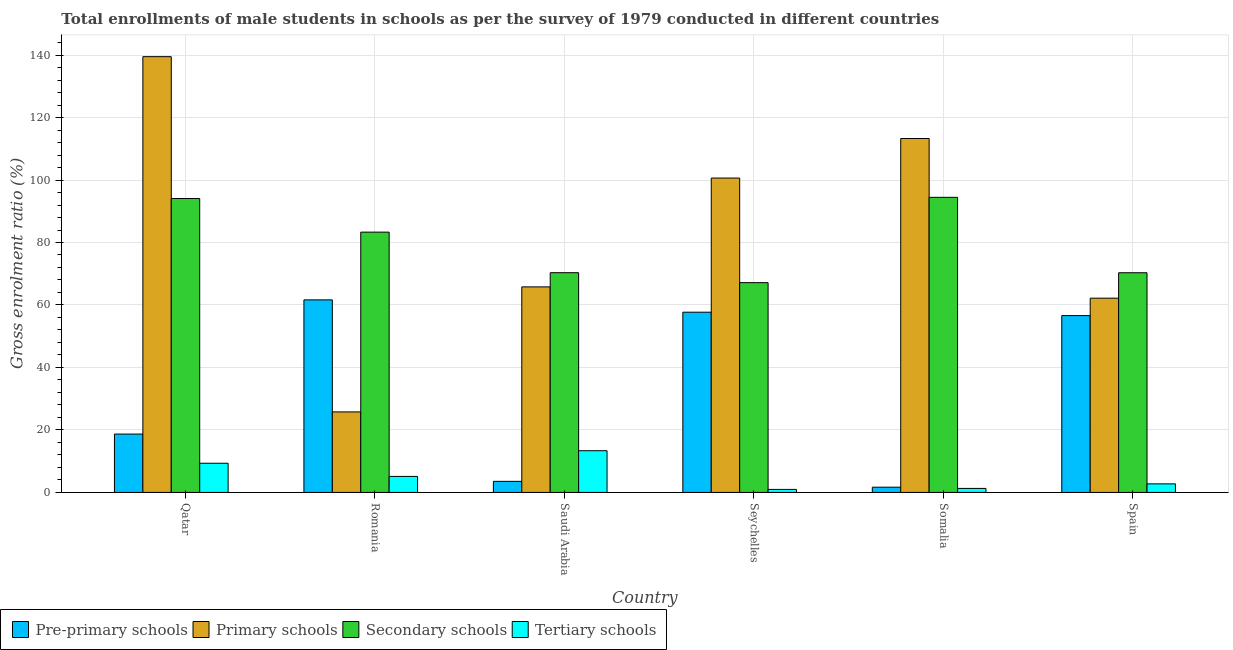How many groups of bars are there?
Offer a terse response. 6. How many bars are there on the 3rd tick from the left?
Offer a terse response. 4. How many bars are there on the 1st tick from the right?
Give a very brief answer. 4. What is the label of the 5th group of bars from the left?
Your answer should be very brief. Somalia. In how many cases, is the number of bars for a given country not equal to the number of legend labels?
Your answer should be very brief. 0. What is the gross enrolment ratio(male) in tertiary schools in Somalia?
Your answer should be very brief. 1.29. Across all countries, what is the maximum gross enrolment ratio(male) in secondary schools?
Ensure brevity in your answer.  94.46. Across all countries, what is the minimum gross enrolment ratio(male) in tertiary schools?
Keep it short and to the point. 0.97. In which country was the gross enrolment ratio(male) in pre-primary schools maximum?
Ensure brevity in your answer.  Romania. In which country was the gross enrolment ratio(male) in primary schools minimum?
Your answer should be very brief. Romania. What is the total gross enrolment ratio(male) in primary schools in the graph?
Ensure brevity in your answer.  507.15. What is the difference between the gross enrolment ratio(male) in primary schools in Seychelles and that in Spain?
Make the answer very short. 38.44. What is the difference between the gross enrolment ratio(male) in tertiary schools in Qatar and the gross enrolment ratio(male) in secondary schools in Romania?
Offer a very short reply. -73.97. What is the average gross enrolment ratio(male) in secondary schools per country?
Offer a very short reply. 79.94. What is the difference between the gross enrolment ratio(male) in tertiary schools and gross enrolment ratio(male) in primary schools in Qatar?
Provide a succinct answer. -130.14. In how many countries, is the gross enrolment ratio(male) in tertiary schools greater than 108 %?
Offer a terse response. 0. What is the ratio of the gross enrolment ratio(male) in primary schools in Romania to that in Spain?
Your answer should be very brief. 0.41. Is the gross enrolment ratio(male) in pre-primary schools in Romania less than that in Seychelles?
Keep it short and to the point. No. Is the difference between the gross enrolment ratio(male) in secondary schools in Qatar and Spain greater than the difference between the gross enrolment ratio(male) in primary schools in Qatar and Spain?
Your response must be concise. No. What is the difference between the highest and the second highest gross enrolment ratio(male) in primary schools?
Give a very brief answer. 26.19. What is the difference between the highest and the lowest gross enrolment ratio(male) in pre-primary schools?
Your response must be concise. 59.96. What does the 2nd bar from the left in Spain represents?
Make the answer very short. Primary schools. What does the 3rd bar from the right in Spain represents?
Offer a very short reply. Primary schools. Are all the bars in the graph horizontal?
Offer a very short reply. No. Are the values on the major ticks of Y-axis written in scientific E-notation?
Offer a very short reply. No. Does the graph contain grids?
Provide a succinct answer. Yes. Where does the legend appear in the graph?
Offer a terse response. Bottom left. What is the title of the graph?
Make the answer very short. Total enrollments of male students in schools as per the survey of 1979 conducted in different countries. What is the label or title of the X-axis?
Make the answer very short. Country. What is the Gross enrolment ratio (%) in Pre-primary schools in Qatar?
Give a very brief answer. 18.68. What is the Gross enrolment ratio (%) of Primary schools in Qatar?
Provide a short and direct response. 139.48. What is the Gross enrolment ratio (%) of Secondary schools in Qatar?
Offer a terse response. 94.08. What is the Gross enrolment ratio (%) in Tertiary schools in Qatar?
Your answer should be compact. 9.34. What is the Gross enrolment ratio (%) in Pre-primary schools in Romania?
Your response must be concise. 61.64. What is the Gross enrolment ratio (%) of Primary schools in Romania?
Offer a terse response. 25.77. What is the Gross enrolment ratio (%) of Secondary schools in Romania?
Offer a very short reply. 83.32. What is the Gross enrolment ratio (%) in Tertiary schools in Romania?
Give a very brief answer. 5.13. What is the Gross enrolment ratio (%) in Pre-primary schools in Saudi Arabia?
Offer a very short reply. 3.55. What is the Gross enrolment ratio (%) of Primary schools in Saudi Arabia?
Make the answer very short. 65.8. What is the Gross enrolment ratio (%) of Secondary schools in Saudi Arabia?
Your answer should be very brief. 70.33. What is the Gross enrolment ratio (%) in Tertiary schools in Saudi Arabia?
Your answer should be very brief. 13.35. What is the Gross enrolment ratio (%) in Pre-primary schools in Seychelles?
Make the answer very short. 57.69. What is the Gross enrolment ratio (%) of Primary schools in Seychelles?
Your answer should be very brief. 100.63. What is the Gross enrolment ratio (%) in Secondary schools in Seychelles?
Give a very brief answer. 67.15. What is the Gross enrolment ratio (%) in Tertiary schools in Seychelles?
Your response must be concise. 0.97. What is the Gross enrolment ratio (%) of Pre-primary schools in Somalia?
Give a very brief answer. 1.68. What is the Gross enrolment ratio (%) in Primary schools in Somalia?
Make the answer very short. 113.29. What is the Gross enrolment ratio (%) of Secondary schools in Somalia?
Your answer should be very brief. 94.46. What is the Gross enrolment ratio (%) in Tertiary schools in Somalia?
Make the answer very short. 1.29. What is the Gross enrolment ratio (%) of Pre-primary schools in Spain?
Your response must be concise. 56.6. What is the Gross enrolment ratio (%) of Primary schools in Spain?
Your answer should be compact. 62.18. What is the Gross enrolment ratio (%) of Secondary schools in Spain?
Ensure brevity in your answer.  70.32. What is the Gross enrolment ratio (%) of Tertiary schools in Spain?
Provide a short and direct response. 2.74. Across all countries, what is the maximum Gross enrolment ratio (%) of Pre-primary schools?
Keep it short and to the point. 61.64. Across all countries, what is the maximum Gross enrolment ratio (%) of Primary schools?
Ensure brevity in your answer.  139.48. Across all countries, what is the maximum Gross enrolment ratio (%) in Secondary schools?
Provide a succinct answer. 94.46. Across all countries, what is the maximum Gross enrolment ratio (%) of Tertiary schools?
Your answer should be compact. 13.35. Across all countries, what is the minimum Gross enrolment ratio (%) in Pre-primary schools?
Your response must be concise. 1.68. Across all countries, what is the minimum Gross enrolment ratio (%) of Primary schools?
Your answer should be very brief. 25.77. Across all countries, what is the minimum Gross enrolment ratio (%) in Secondary schools?
Your response must be concise. 67.15. Across all countries, what is the minimum Gross enrolment ratio (%) of Tertiary schools?
Make the answer very short. 0.97. What is the total Gross enrolment ratio (%) in Pre-primary schools in the graph?
Your answer should be very brief. 199.83. What is the total Gross enrolment ratio (%) of Primary schools in the graph?
Provide a short and direct response. 507.15. What is the total Gross enrolment ratio (%) in Secondary schools in the graph?
Offer a very short reply. 479.66. What is the total Gross enrolment ratio (%) of Tertiary schools in the graph?
Your answer should be very brief. 32.83. What is the difference between the Gross enrolment ratio (%) of Pre-primary schools in Qatar and that in Romania?
Make the answer very short. -42.95. What is the difference between the Gross enrolment ratio (%) of Primary schools in Qatar and that in Romania?
Make the answer very short. 113.71. What is the difference between the Gross enrolment ratio (%) in Secondary schools in Qatar and that in Romania?
Offer a terse response. 10.76. What is the difference between the Gross enrolment ratio (%) in Tertiary schools in Qatar and that in Romania?
Give a very brief answer. 4.22. What is the difference between the Gross enrolment ratio (%) in Pre-primary schools in Qatar and that in Saudi Arabia?
Make the answer very short. 15.13. What is the difference between the Gross enrolment ratio (%) in Primary schools in Qatar and that in Saudi Arabia?
Your answer should be compact. 73.69. What is the difference between the Gross enrolment ratio (%) in Secondary schools in Qatar and that in Saudi Arabia?
Make the answer very short. 23.74. What is the difference between the Gross enrolment ratio (%) in Tertiary schools in Qatar and that in Saudi Arabia?
Your answer should be compact. -4.01. What is the difference between the Gross enrolment ratio (%) in Pre-primary schools in Qatar and that in Seychelles?
Offer a very short reply. -39.01. What is the difference between the Gross enrolment ratio (%) in Primary schools in Qatar and that in Seychelles?
Your answer should be compact. 38.86. What is the difference between the Gross enrolment ratio (%) of Secondary schools in Qatar and that in Seychelles?
Make the answer very short. 26.93. What is the difference between the Gross enrolment ratio (%) of Tertiary schools in Qatar and that in Seychelles?
Make the answer very short. 8.38. What is the difference between the Gross enrolment ratio (%) of Pre-primary schools in Qatar and that in Somalia?
Make the answer very short. 17.01. What is the difference between the Gross enrolment ratio (%) of Primary schools in Qatar and that in Somalia?
Your answer should be compact. 26.19. What is the difference between the Gross enrolment ratio (%) in Secondary schools in Qatar and that in Somalia?
Give a very brief answer. -0.38. What is the difference between the Gross enrolment ratio (%) of Tertiary schools in Qatar and that in Somalia?
Ensure brevity in your answer.  8.06. What is the difference between the Gross enrolment ratio (%) in Pre-primary schools in Qatar and that in Spain?
Provide a short and direct response. -37.92. What is the difference between the Gross enrolment ratio (%) in Primary schools in Qatar and that in Spain?
Your answer should be compact. 77.3. What is the difference between the Gross enrolment ratio (%) of Secondary schools in Qatar and that in Spain?
Keep it short and to the point. 23.75. What is the difference between the Gross enrolment ratio (%) in Tertiary schools in Qatar and that in Spain?
Ensure brevity in your answer.  6.6. What is the difference between the Gross enrolment ratio (%) of Pre-primary schools in Romania and that in Saudi Arabia?
Ensure brevity in your answer.  58.09. What is the difference between the Gross enrolment ratio (%) of Primary schools in Romania and that in Saudi Arabia?
Ensure brevity in your answer.  -40.02. What is the difference between the Gross enrolment ratio (%) of Secondary schools in Romania and that in Saudi Arabia?
Offer a terse response. 12.98. What is the difference between the Gross enrolment ratio (%) of Tertiary schools in Romania and that in Saudi Arabia?
Ensure brevity in your answer.  -8.23. What is the difference between the Gross enrolment ratio (%) of Pre-primary schools in Romania and that in Seychelles?
Offer a very short reply. 3.94. What is the difference between the Gross enrolment ratio (%) of Primary schools in Romania and that in Seychelles?
Ensure brevity in your answer.  -74.85. What is the difference between the Gross enrolment ratio (%) in Secondary schools in Romania and that in Seychelles?
Keep it short and to the point. 16.17. What is the difference between the Gross enrolment ratio (%) of Tertiary schools in Romania and that in Seychelles?
Provide a succinct answer. 4.16. What is the difference between the Gross enrolment ratio (%) in Pre-primary schools in Romania and that in Somalia?
Provide a succinct answer. 59.96. What is the difference between the Gross enrolment ratio (%) of Primary schools in Romania and that in Somalia?
Offer a very short reply. -87.52. What is the difference between the Gross enrolment ratio (%) in Secondary schools in Romania and that in Somalia?
Offer a terse response. -11.14. What is the difference between the Gross enrolment ratio (%) of Tertiary schools in Romania and that in Somalia?
Your answer should be compact. 3.84. What is the difference between the Gross enrolment ratio (%) in Pre-primary schools in Romania and that in Spain?
Offer a very short reply. 5.03. What is the difference between the Gross enrolment ratio (%) in Primary schools in Romania and that in Spain?
Your response must be concise. -36.41. What is the difference between the Gross enrolment ratio (%) of Secondary schools in Romania and that in Spain?
Make the answer very short. 12.99. What is the difference between the Gross enrolment ratio (%) in Tertiary schools in Romania and that in Spain?
Offer a terse response. 2.38. What is the difference between the Gross enrolment ratio (%) of Pre-primary schools in Saudi Arabia and that in Seychelles?
Provide a short and direct response. -54.15. What is the difference between the Gross enrolment ratio (%) in Primary schools in Saudi Arabia and that in Seychelles?
Keep it short and to the point. -34.83. What is the difference between the Gross enrolment ratio (%) of Secondary schools in Saudi Arabia and that in Seychelles?
Your response must be concise. 3.19. What is the difference between the Gross enrolment ratio (%) of Tertiary schools in Saudi Arabia and that in Seychelles?
Give a very brief answer. 12.39. What is the difference between the Gross enrolment ratio (%) in Pre-primary schools in Saudi Arabia and that in Somalia?
Make the answer very short. 1.87. What is the difference between the Gross enrolment ratio (%) of Primary schools in Saudi Arabia and that in Somalia?
Your answer should be very brief. -47.49. What is the difference between the Gross enrolment ratio (%) of Secondary schools in Saudi Arabia and that in Somalia?
Your answer should be compact. -24.12. What is the difference between the Gross enrolment ratio (%) of Tertiary schools in Saudi Arabia and that in Somalia?
Your answer should be very brief. 12.07. What is the difference between the Gross enrolment ratio (%) in Pre-primary schools in Saudi Arabia and that in Spain?
Your response must be concise. -53.06. What is the difference between the Gross enrolment ratio (%) of Primary schools in Saudi Arabia and that in Spain?
Ensure brevity in your answer.  3.61. What is the difference between the Gross enrolment ratio (%) in Secondary schools in Saudi Arabia and that in Spain?
Make the answer very short. 0.01. What is the difference between the Gross enrolment ratio (%) in Tertiary schools in Saudi Arabia and that in Spain?
Offer a terse response. 10.61. What is the difference between the Gross enrolment ratio (%) in Pre-primary schools in Seychelles and that in Somalia?
Give a very brief answer. 56.02. What is the difference between the Gross enrolment ratio (%) of Primary schools in Seychelles and that in Somalia?
Provide a succinct answer. -12.66. What is the difference between the Gross enrolment ratio (%) in Secondary schools in Seychelles and that in Somalia?
Ensure brevity in your answer.  -27.31. What is the difference between the Gross enrolment ratio (%) in Tertiary schools in Seychelles and that in Somalia?
Your answer should be very brief. -0.32. What is the difference between the Gross enrolment ratio (%) of Pre-primary schools in Seychelles and that in Spain?
Keep it short and to the point. 1.09. What is the difference between the Gross enrolment ratio (%) in Primary schools in Seychelles and that in Spain?
Give a very brief answer. 38.44. What is the difference between the Gross enrolment ratio (%) of Secondary schools in Seychelles and that in Spain?
Provide a succinct answer. -3.17. What is the difference between the Gross enrolment ratio (%) in Tertiary schools in Seychelles and that in Spain?
Your answer should be compact. -1.78. What is the difference between the Gross enrolment ratio (%) in Pre-primary schools in Somalia and that in Spain?
Offer a terse response. -54.93. What is the difference between the Gross enrolment ratio (%) in Primary schools in Somalia and that in Spain?
Your answer should be compact. 51.11. What is the difference between the Gross enrolment ratio (%) in Secondary schools in Somalia and that in Spain?
Your answer should be compact. 24.13. What is the difference between the Gross enrolment ratio (%) of Tertiary schools in Somalia and that in Spain?
Your answer should be very brief. -1.46. What is the difference between the Gross enrolment ratio (%) of Pre-primary schools in Qatar and the Gross enrolment ratio (%) of Primary schools in Romania?
Offer a very short reply. -7.09. What is the difference between the Gross enrolment ratio (%) in Pre-primary schools in Qatar and the Gross enrolment ratio (%) in Secondary schools in Romania?
Keep it short and to the point. -64.64. What is the difference between the Gross enrolment ratio (%) of Pre-primary schools in Qatar and the Gross enrolment ratio (%) of Tertiary schools in Romania?
Your response must be concise. 13.55. What is the difference between the Gross enrolment ratio (%) in Primary schools in Qatar and the Gross enrolment ratio (%) in Secondary schools in Romania?
Give a very brief answer. 56.17. What is the difference between the Gross enrolment ratio (%) in Primary schools in Qatar and the Gross enrolment ratio (%) in Tertiary schools in Romania?
Offer a terse response. 134.36. What is the difference between the Gross enrolment ratio (%) in Secondary schools in Qatar and the Gross enrolment ratio (%) in Tertiary schools in Romania?
Keep it short and to the point. 88.95. What is the difference between the Gross enrolment ratio (%) in Pre-primary schools in Qatar and the Gross enrolment ratio (%) in Primary schools in Saudi Arabia?
Provide a succinct answer. -47.12. What is the difference between the Gross enrolment ratio (%) of Pre-primary schools in Qatar and the Gross enrolment ratio (%) of Secondary schools in Saudi Arabia?
Provide a short and direct response. -51.65. What is the difference between the Gross enrolment ratio (%) in Pre-primary schools in Qatar and the Gross enrolment ratio (%) in Tertiary schools in Saudi Arabia?
Your answer should be very brief. 5.33. What is the difference between the Gross enrolment ratio (%) in Primary schools in Qatar and the Gross enrolment ratio (%) in Secondary schools in Saudi Arabia?
Your answer should be compact. 69.15. What is the difference between the Gross enrolment ratio (%) of Primary schools in Qatar and the Gross enrolment ratio (%) of Tertiary schools in Saudi Arabia?
Your response must be concise. 126.13. What is the difference between the Gross enrolment ratio (%) in Secondary schools in Qatar and the Gross enrolment ratio (%) in Tertiary schools in Saudi Arabia?
Your answer should be compact. 80.72. What is the difference between the Gross enrolment ratio (%) of Pre-primary schools in Qatar and the Gross enrolment ratio (%) of Primary schools in Seychelles?
Offer a terse response. -81.95. What is the difference between the Gross enrolment ratio (%) in Pre-primary schools in Qatar and the Gross enrolment ratio (%) in Secondary schools in Seychelles?
Your answer should be very brief. -48.47. What is the difference between the Gross enrolment ratio (%) in Pre-primary schools in Qatar and the Gross enrolment ratio (%) in Tertiary schools in Seychelles?
Your answer should be compact. 17.71. What is the difference between the Gross enrolment ratio (%) of Primary schools in Qatar and the Gross enrolment ratio (%) of Secondary schools in Seychelles?
Your answer should be very brief. 72.34. What is the difference between the Gross enrolment ratio (%) in Primary schools in Qatar and the Gross enrolment ratio (%) in Tertiary schools in Seychelles?
Provide a short and direct response. 138.52. What is the difference between the Gross enrolment ratio (%) in Secondary schools in Qatar and the Gross enrolment ratio (%) in Tertiary schools in Seychelles?
Keep it short and to the point. 93.11. What is the difference between the Gross enrolment ratio (%) in Pre-primary schools in Qatar and the Gross enrolment ratio (%) in Primary schools in Somalia?
Ensure brevity in your answer.  -94.61. What is the difference between the Gross enrolment ratio (%) of Pre-primary schools in Qatar and the Gross enrolment ratio (%) of Secondary schools in Somalia?
Offer a terse response. -75.78. What is the difference between the Gross enrolment ratio (%) of Pre-primary schools in Qatar and the Gross enrolment ratio (%) of Tertiary schools in Somalia?
Provide a succinct answer. 17.39. What is the difference between the Gross enrolment ratio (%) of Primary schools in Qatar and the Gross enrolment ratio (%) of Secondary schools in Somalia?
Provide a succinct answer. 45.03. What is the difference between the Gross enrolment ratio (%) of Primary schools in Qatar and the Gross enrolment ratio (%) of Tertiary schools in Somalia?
Provide a succinct answer. 138.2. What is the difference between the Gross enrolment ratio (%) in Secondary schools in Qatar and the Gross enrolment ratio (%) in Tertiary schools in Somalia?
Your answer should be compact. 92.79. What is the difference between the Gross enrolment ratio (%) of Pre-primary schools in Qatar and the Gross enrolment ratio (%) of Primary schools in Spain?
Give a very brief answer. -43.5. What is the difference between the Gross enrolment ratio (%) of Pre-primary schools in Qatar and the Gross enrolment ratio (%) of Secondary schools in Spain?
Keep it short and to the point. -51.64. What is the difference between the Gross enrolment ratio (%) in Pre-primary schools in Qatar and the Gross enrolment ratio (%) in Tertiary schools in Spain?
Make the answer very short. 15.94. What is the difference between the Gross enrolment ratio (%) of Primary schools in Qatar and the Gross enrolment ratio (%) of Secondary schools in Spain?
Ensure brevity in your answer.  69.16. What is the difference between the Gross enrolment ratio (%) of Primary schools in Qatar and the Gross enrolment ratio (%) of Tertiary schools in Spain?
Your answer should be very brief. 136.74. What is the difference between the Gross enrolment ratio (%) in Secondary schools in Qatar and the Gross enrolment ratio (%) in Tertiary schools in Spain?
Your answer should be compact. 91.33. What is the difference between the Gross enrolment ratio (%) of Pre-primary schools in Romania and the Gross enrolment ratio (%) of Primary schools in Saudi Arabia?
Offer a very short reply. -4.16. What is the difference between the Gross enrolment ratio (%) of Pre-primary schools in Romania and the Gross enrolment ratio (%) of Secondary schools in Saudi Arabia?
Provide a succinct answer. -8.7. What is the difference between the Gross enrolment ratio (%) in Pre-primary schools in Romania and the Gross enrolment ratio (%) in Tertiary schools in Saudi Arabia?
Offer a terse response. 48.28. What is the difference between the Gross enrolment ratio (%) in Primary schools in Romania and the Gross enrolment ratio (%) in Secondary schools in Saudi Arabia?
Offer a terse response. -44.56. What is the difference between the Gross enrolment ratio (%) in Primary schools in Romania and the Gross enrolment ratio (%) in Tertiary schools in Saudi Arabia?
Offer a terse response. 12.42. What is the difference between the Gross enrolment ratio (%) of Secondary schools in Romania and the Gross enrolment ratio (%) of Tertiary schools in Saudi Arabia?
Make the answer very short. 69.96. What is the difference between the Gross enrolment ratio (%) in Pre-primary schools in Romania and the Gross enrolment ratio (%) in Primary schools in Seychelles?
Make the answer very short. -38.99. What is the difference between the Gross enrolment ratio (%) of Pre-primary schools in Romania and the Gross enrolment ratio (%) of Secondary schools in Seychelles?
Ensure brevity in your answer.  -5.51. What is the difference between the Gross enrolment ratio (%) of Pre-primary schools in Romania and the Gross enrolment ratio (%) of Tertiary schools in Seychelles?
Offer a very short reply. 60.67. What is the difference between the Gross enrolment ratio (%) of Primary schools in Romania and the Gross enrolment ratio (%) of Secondary schools in Seychelles?
Make the answer very short. -41.38. What is the difference between the Gross enrolment ratio (%) in Primary schools in Romania and the Gross enrolment ratio (%) in Tertiary schools in Seychelles?
Provide a succinct answer. 24.8. What is the difference between the Gross enrolment ratio (%) of Secondary schools in Romania and the Gross enrolment ratio (%) of Tertiary schools in Seychelles?
Give a very brief answer. 82.35. What is the difference between the Gross enrolment ratio (%) in Pre-primary schools in Romania and the Gross enrolment ratio (%) in Primary schools in Somalia?
Provide a short and direct response. -51.65. What is the difference between the Gross enrolment ratio (%) in Pre-primary schools in Romania and the Gross enrolment ratio (%) in Secondary schools in Somalia?
Give a very brief answer. -32.82. What is the difference between the Gross enrolment ratio (%) in Pre-primary schools in Romania and the Gross enrolment ratio (%) in Tertiary schools in Somalia?
Offer a terse response. 60.35. What is the difference between the Gross enrolment ratio (%) in Primary schools in Romania and the Gross enrolment ratio (%) in Secondary schools in Somalia?
Provide a short and direct response. -68.68. What is the difference between the Gross enrolment ratio (%) of Primary schools in Romania and the Gross enrolment ratio (%) of Tertiary schools in Somalia?
Give a very brief answer. 24.48. What is the difference between the Gross enrolment ratio (%) in Secondary schools in Romania and the Gross enrolment ratio (%) in Tertiary schools in Somalia?
Make the answer very short. 82.03. What is the difference between the Gross enrolment ratio (%) of Pre-primary schools in Romania and the Gross enrolment ratio (%) of Primary schools in Spain?
Keep it short and to the point. -0.55. What is the difference between the Gross enrolment ratio (%) in Pre-primary schools in Romania and the Gross enrolment ratio (%) in Secondary schools in Spain?
Make the answer very short. -8.69. What is the difference between the Gross enrolment ratio (%) in Pre-primary schools in Romania and the Gross enrolment ratio (%) in Tertiary schools in Spain?
Make the answer very short. 58.89. What is the difference between the Gross enrolment ratio (%) of Primary schools in Romania and the Gross enrolment ratio (%) of Secondary schools in Spain?
Offer a very short reply. -44.55. What is the difference between the Gross enrolment ratio (%) of Primary schools in Romania and the Gross enrolment ratio (%) of Tertiary schools in Spain?
Give a very brief answer. 23.03. What is the difference between the Gross enrolment ratio (%) of Secondary schools in Romania and the Gross enrolment ratio (%) of Tertiary schools in Spain?
Your answer should be compact. 80.57. What is the difference between the Gross enrolment ratio (%) of Pre-primary schools in Saudi Arabia and the Gross enrolment ratio (%) of Primary schools in Seychelles?
Ensure brevity in your answer.  -97.08. What is the difference between the Gross enrolment ratio (%) of Pre-primary schools in Saudi Arabia and the Gross enrolment ratio (%) of Secondary schools in Seychelles?
Offer a very short reply. -63.6. What is the difference between the Gross enrolment ratio (%) in Pre-primary schools in Saudi Arabia and the Gross enrolment ratio (%) in Tertiary schools in Seychelles?
Ensure brevity in your answer.  2.58. What is the difference between the Gross enrolment ratio (%) in Primary schools in Saudi Arabia and the Gross enrolment ratio (%) in Secondary schools in Seychelles?
Give a very brief answer. -1.35. What is the difference between the Gross enrolment ratio (%) of Primary schools in Saudi Arabia and the Gross enrolment ratio (%) of Tertiary schools in Seychelles?
Give a very brief answer. 64.83. What is the difference between the Gross enrolment ratio (%) of Secondary schools in Saudi Arabia and the Gross enrolment ratio (%) of Tertiary schools in Seychelles?
Your answer should be compact. 69.37. What is the difference between the Gross enrolment ratio (%) of Pre-primary schools in Saudi Arabia and the Gross enrolment ratio (%) of Primary schools in Somalia?
Keep it short and to the point. -109.74. What is the difference between the Gross enrolment ratio (%) in Pre-primary schools in Saudi Arabia and the Gross enrolment ratio (%) in Secondary schools in Somalia?
Keep it short and to the point. -90.91. What is the difference between the Gross enrolment ratio (%) of Pre-primary schools in Saudi Arabia and the Gross enrolment ratio (%) of Tertiary schools in Somalia?
Make the answer very short. 2.26. What is the difference between the Gross enrolment ratio (%) in Primary schools in Saudi Arabia and the Gross enrolment ratio (%) in Secondary schools in Somalia?
Your response must be concise. -28.66. What is the difference between the Gross enrolment ratio (%) of Primary schools in Saudi Arabia and the Gross enrolment ratio (%) of Tertiary schools in Somalia?
Ensure brevity in your answer.  64.51. What is the difference between the Gross enrolment ratio (%) in Secondary schools in Saudi Arabia and the Gross enrolment ratio (%) in Tertiary schools in Somalia?
Make the answer very short. 69.05. What is the difference between the Gross enrolment ratio (%) of Pre-primary schools in Saudi Arabia and the Gross enrolment ratio (%) of Primary schools in Spain?
Your answer should be very brief. -58.64. What is the difference between the Gross enrolment ratio (%) of Pre-primary schools in Saudi Arabia and the Gross enrolment ratio (%) of Secondary schools in Spain?
Your answer should be very brief. -66.78. What is the difference between the Gross enrolment ratio (%) in Pre-primary schools in Saudi Arabia and the Gross enrolment ratio (%) in Tertiary schools in Spain?
Provide a short and direct response. 0.8. What is the difference between the Gross enrolment ratio (%) of Primary schools in Saudi Arabia and the Gross enrolment ratio (%) of Secondary schools in Spain?
Your answer should be compact. -4.53. What is the difference between the Gross enrolment ratio (%) of Primary schools in Saudi Arabia and the Gross enrolment ratio (%) of Tertiary schools in Spain?
Keep it short and to the point. 63.05. What is the difference between the Gross enrolment ratio (%) of Secondary schools in Saudi Arabia and the Gross enrolment ratio (%) of Tertiary schools in Spain?
Offer a very short reply. 67.59. What is the difference between the Gross enrolment ratio (%) of Pre-primary schools in Seychelles and the Gross enrolment ratio (%) of Primary schools in Somalia?
Make the answer very short. -55.6. What is the difference between the Gross enrolment ratio (%) of Pre-primary schools in Seychelles and the Gross enrolment ratio (%) of Secondary schools in Somalia?
Ensure brevity in your answer.  -36.76. What is the difference between the Gross enrolment ratio (%) in Pre-primary schools in Seychelles and the Gross enrolment ratio (%) in Tertiary schools in Somalia?
Your answer should be very brief. 56.4. What is the difference between the Gross enrolment ratio (%) in Primary schools in Seychelles and the Gross enrolment ratio (%) in Secondary schools in Somalia?
Give a very brief answer. 6.17. What is the difference between the Gross enrolment ratio (%) of Primary schools in Seychelles and the Gross enrolment ratio (%) of Tertiary schools in Somalia?
Your response must be concise. 99.34. What is the difference between the Gross enrolment ratio (%) of Secondary schools in Seychelles and the Gross enrolment ratio (%) of Tertiary schools in Somalia?
Your answer should be very brief. 65.86. What is the difference between the Gross enrolment ratio (%) in Pre-primary schools in Seychelles and the Gross enrolment ratio (%) in Primary schools in Spain?
Your answer should be very brief. -4.49. What is the difference between the Gross enrolment ratio (%) in Pre-primary schools in Seychelles and the Gross enrolment ratio (%) in Secondary schools in Spain?
Your answer should be compact. -12.63. What is the difference between the Gross enrolment ratio (%) of Pre-primary schools in Seychelles and the Gross enrolment ratio (%) of Tertiary schools in Spain?
Provide a succinct answer. 54.95. What is the difference between the Gross enrolment ratio (%) in Primary schools in Seychelles and the Gross enrolment ratio (%) in Secondary schools in Spain?
Offer a terse response. 30.3. What is the difference between the Gross enrolment ratio (%) of Primary schools in Seychelles and the Gross enrolment ratio (%) of Tertiary schools in Spain?
Your response must be concise. 97.88. What is the difference between the Gross enrolment ratio (%) of Secondary schools in Seychelles and the Gross enrolment ratio (%) of Tertiary schools in Spain?
Give a very brief answer. 64.4. What is the difference between the Gross enrolment ratio (%) of Pre-primary schools in Somalia and the Gross enrolment ratio (%) of Primary schools in Spain?
Keep it short and to the point. -60.51. What is the difference between the Gross enrolment ratio (%) of Pre-primary schools in Somalia and the Gross enrolment ratio (%) of Secondary schools in Spain?
Ensure brevity in your answer.  -68.65. What is the difference between the Gross enrolment ratio (%) in Pre-primary schools in Somalia and the Gross enrolment ratio (%) in Tertiary schools in Spain?
Give a very brief answer. -1.07. What is the difference between the Gross enrolment ratio (%) of Primary schools in Somalia and the Gross enrolment ratio (%) of Secondary schools in Spain?
Your response must be concise. 42.97. What is the difference between the Gross enrolment ratio (%) of Primary schools in Somalia and the Gross enrolment ratio (%) of Tertiary schools in Spain?
Offer a very short reply. 110.54. What is the difference between the Gross enrolment ratio (%) of Secondary schools in Somalia and the Gross enrolment ratio (%) of Tertiary schools in Spain?
Give a very brief answer. 91.71. What is the average Gross enrolment ratio (%) in Pre-primary schools per country?
Make the answer very short. 33.31. What is the average Gross enrolment ratio (%) of Primary schools per country?
Offer a very short reply. 84.53. What is the average Gross enrolment ratio (%) in Secondary schools per country?
Your response must be concise. 79.94. What is the average Gross enrolment ratio (%) of Tertiary schools per country?
Provide a succinct answer. 5.47. What is the difference between the Gross enrolment ratio (%) of Pre-primary schools and Gross enrolment ratio (%) of Primary schools in Qatar?
Ensure brevity in your answer.  -120.8. What is the difference between the Gross enrolment ratio (%) in Pre-primary schools and Gross enrolment ratio (%) in Secondary schools in Qatar?
Your answer should be compact. -75.39. What is the difference between the Gross enrolment ratio (%) of Pre-primary schools and Gross enrolment ratio (%) of Tertiary schools in Qatar?
Make the answer very short. 9.34. What is the difference between the Gross enrolment ratio (%) in Primary schools and Gross enrolment ratio (%) in Secondary schools in Qatar?
Your answer should be very brief. 45.41. What is the difference between the Gross enrolment ratio (%) in Primary schools and Gross enrolment ratio (%) in Tertiary schools in Qatar?
Give a very brief answer. 130.14. What is the difference between the Gross enrolment ratio (%) of Secondary schools and Gross enrolment ratio (%) of Tertiary schools in Qatar?
Offer a terse response. 84.73. What is the difference between the Gross enrolment ratio (%) in Pre-primary schools and Gross enrolment ratio (%) in Primary schools in Romania?
Provide a short and direct response. 35.86. What is the difference between the Gross enrolment ratio (%) in Pre-primary schools and Gross enrolment ratio (%) in Secondary schools in Romania?
Offer a very short reply. -21.68. What is the difference between the Gross enrolment ratio (%) of Pre-primary schools and Gross enrolment ratio (%) of Tertiary schools in Romania?
Offer a terse response. 56.51. What is the difference between the Gross enrolment ratio (%) of Primary schools and Gross enrolment ratio (%) of Secondary schools in Romania?
Your response must be concise. -57.54. What is the difference between the Gross enrolment ratio (%) of Primary schools and Gross enrolment ratio (%) of Tertiary schools in Romania?
Your answer should be compact. 20.64. What is the difference between the Gross enrolment ratio (%) in Secondary schools and Gross enrolment ratio (%) in Tertiary schools in Romania?
Make the answer very short. 78.19. What is the difference between the Gross enrolment ratio (%) in Pre-primary schools and Gross enrolment ratio (%) in Primary schools in Saudi Arabia?
Offer a very short reply. -62.25. What is the difference between the Gross enrolment ratio (%) in Pre-primary schools and Gross enrolment ratio (%) in Secondary schools in Saudi Arabia?
Ensure brevity in your answer.  -66.79. What is the difference between the Gross enrolment ratio (%) in Pre-primary schools and Gross enrolment ratio (%) in Tertiary schools in Saudi Arabia?
Keep it short and to the point. -9.81. What is the difference between the Gross enrolment ratio (%) in Primary schools and Gross enrolment ratio (%) in Secondary schools in Saudi Arabia?
Ensure brevity in your answer.  -4.54. What is the difference between the Gross enrolment ratio (%) of Primary schools and Gross enrolment ratio (%) of Tertiary schools in Saudi Arabia?
Offer a terse response. 52.44. What is the difference between the Gross enrolment ratio (%) in Secondary schools and Gross enrolment ratio (%) in Tertiary schools in Saudi Arabia?
Provide a succinct answer. 56.98. What is the difference between the Gross enrolment ratio (%) of Pre-primary schools and Gross enrolment ratio (%) of Primary schools in Seychelles?
Keep it short and to the point. -42.93. What is the difference between the Gross enrolment ratio (%) in Pre-primary schools and Gross enrolment ratio (%) in Secondary schools in Seychelles?
Your response must be concise. -9.46. What is the difference between the Gross enrolment ratio (%) in Pre-primary schools and Gross enrolment ratio (%) in Tertiary schools in Seychelles?
Provide a succinct answer. 56.72. What is the difference between the Gross enrolment ratio (%) of Primary schools and Gross enrolment ratio (%) of Secondary schools in Seychelles?
Make the answer very short. 33.48. What is the difference between the Gross enrolment ratio (%) of Primary schools and Gross enrolment ratio (%) of Tertiary schools in Seychelles?
Ensure brevity in your answer.  99.66. What is the difference between the Gross enrolment ratio (%) in Secondary schools and Gross enrolment ratio (%) in Tertiary schools in Seychelles?
Provide a succinct answer. 66.18. What is the difference between the Gross enrolment ratio (%) of Pre-primary schools and Gross enrolment ratio (%) of Primary schools in Somalia?
Make the answer very short. -111.61. What is the difference between the Gross enrolment ratio (%) in Pre-primary schools and Gross enrolment ratio (%) in Secondary schools in Somalia?
Give a very brief answer. -92.78. What is the difference between the Gross enrolment ratio (%) of Pre-primary schools and Gross enrolment ratio (%) of Tertiary schools in Somalia?
Offer a terse response. 0.39. What is the difference between the Gross enrolment ratio (%) in Primary schools and Gross enrolment ratio (%) in Secondary schools in Somalia?
Provide a short and direct response. 18.83. What is the difference between the Gross enrolment ratio (%) in Primary schools and Gross enrolment ratio (%) in Tertiary schools in Somalia?
Provide a succinct answer. 112. What is the difference between the Gross enrolment ratio (%) in Secondary schools and Gross enrolment ratio (%) in Tertiary schools in Somalia?
Keep it short and to the point. 93.17. What is the difference between the Gross enrolment ratio (%) of Pre-primary schools and Gross enrolment ratio (%) of Primary schools in Spain?
Your answer should be very brief. -5.58. What is the difference between the Gross enrolment ratio (%) in Pre-primary schools and Gross enrolment ratio (%) in Secondary schools in Spain?
Make the answer very short. -13.72. What is the difference between the Gross enrolment ratio (%) in Pre-primary schools and Gross enrolment ratio (%) in Tertiary schools in Spain?
Provide a succinct answer. 53.86. What is the difference between the Gross enrolment ratio (%) in Primary schools and Gross enrolment ratio (%) in Secondary schools in Spain?
Make the answer very short. -8.14. What is the difference between the Gross enrolment ratio (%) in Primary schools and Gross enrolment ratio (%) in Tertiary schools in Spain?
Your answer should be very brief. 59.44. What is the difference between the Gross enrolment ratio (%) in Secondary schools and Gross enrolment ratio (%) in Tertiary schools in Spain?
Make the answer very short. 67.58. What is the ratio of the Gross enrolment ratio (%) in Pre-primary schools in Qatar to that in Romania?
Ensure brevity in your answer.  0.3. What is the ratio of the Gross enrolment ratio (%) of Primary schools in Qatar to that in Romania?
Ensure brevity in your answer.  5.41. What is the ratio of the Gross enrolment ratio (%) of Secondary schools in Qatar to that in Romania?
Your answer should be very brief. 1.13. What is the ratio of the Gross enrolment ratio (%) of Tertiary schools in Qatar to that in Romania?
Your response must be concise. 1.82. What is the ratio of the Gross enrolment ratio (%) in Pre-primary schools in Qatar to that in Saudi Arabia?
Offer a terse response. 5.27. What is the ratio of the Gross enrolment ratio (%) of Primary schools in Qatar to that in Saudi Arabia?
Give a very brief answer. 2.12. What is the ratio of the Gross enrolment ratio (%) of Secondary schools in Qatar to that in Saudi Arabia?
Keep it short and to the point. 1.34. What is the ratio of the Gross enrolment ratio (%) of Tertiary schools in Qatar to that in Saudi Arabia?
Your answer should be very brief. 0.7. What is the ratio of the Gross enrolment ratio (%) in Pre-primary schools in Qatar to that in Seychelles?
Provide a succinct answer. 0.32. What is the ratio of the Gross enrolment ratio (%) of Primary schools in Qatar to that in Seychelles?
Your response must be concise. 1.39. What is the ratio of the Gross enrolment ratio (%) of Secondary schools in Qatar to that in Seychelles?
Give a very brief answer. 1.4. What is the ratio of the Gross enrolment ratio (%) of Tertiary schools in Qatar to that in Seychelles?
Provide a succinct answer. 9.65. What is the ratio of the Gross enrolment ratio (%) of Pre-primary schools in Qatar to that in Somalia?
Give a very brief answer. 11.15. What is the ratio of the Gross enrolment ratio (%) of Primary schools in Qatar to that in Somalia?
Your response must be concise. 1.23. What is the ratio of the Gross enrolment ratio (%) of Secondary schools in Qatar to that in Somalia?
Your answer should be very brief. 1. What is the ratio of the Gross enrolment ratio (%) in Tertiary schools in Qatar to that in Somalia?
Make the answer very short. 7.26. What is the ratio of the Gross enrolment ratio (%) of Pre-primary schools in Qatar to that in Spain?
Make the answer very short. 0.33. What is the ratio of the Gross enrolment ratio (%) in Primary schools in Qatar to that in Spain?
Your response must be concise. 2.24. What is the ratio of the Gross enrolment ratio (%) in Secondary schools in Qatar to that in Spain?
Provide a short and direct response. 1.34. What is the ratio of the Gross enrolment ratio (%) in Tertiary schools in Qatar to that in Spain?
Make the answer very short. 3.4. What is the ratio of the Gross enrolment ratio (%) of Pre-primary schools in Romania to that in Saudi Arabia?
Make the answer very short. 17.38. What is the ratio of the Gross enrolment ratio (%) of Primary schools in Romania to that in Saudi Arabia?
Your response must be concise. 0.39. What is the ratio of the Gross enrolment ratio (%) of Secondary schools in Romania to that in Saudi Arabia?
Keep it short and to the point. 1.18. What is the ratio of the Gross enrolment ratio (%) of Tertiary schools in Romania to that in Saudi Arabia?
Ensure brevity in your answer.  0.38. What is the ratio of the Gross enrolment ratio (%) of Pre-primary schools in Romania to that in Seychelles?
Your answer should be very brief. 1.07. What is the ratio of the Gross enrolment ratio (%) in Primary schools in Romania to that in Seychelles?
Provide a succinct answer. 0.26. What is the ratio of the Gross enrolment ratio (%) of Secondary schools in Romania to that in Seychelles?
Provide a succinct answer. 1.24. What is the ratio of the Gross enrolment ratio (%) in Tertiary schools in Romania to that in Seychelles?
Keep it short and to the point. 5.29. What is the ratio of the Gross enrolment ratio (%) in Pre-primary schools in Romania to that in Somalia?
Offer a terse response. 36.78. What is the ratio of the Gross enrolment ratio (%) in Primary schools in Romania to that in Somalia?
Provide a succinct answer. 0.23. What is the ratio of the Gross enrolment ratio (%) in Secondary schools in Romania to that in Somalia?
Your answer should be very brief. 0.88. What is the ratio of the Gross enrolment ratio (%) in Tertiary schools in Romania to that in Somalia?
Ensure brevity in your answer.  3.98. What is the ratio of the Gross enrolment ratio (%) in Pre-primary schools in Romania to that in Spain?
Keep it short and to the point. 1.09. What is the ratio of the Gross enrolment ratio (%) of Primary schools in Romania to that in Spain?
Provide a succinct answer. 0.41. What is the ratio of the Gross enrolment ratio (%) in Secondary schools in Romania to that in Spain?
Provide a succinct answer. 1.18. What is the ratio of the Gross enrolment ratio (%) of Tertiary schools in Romania to that in Spain?
Make the answer very short. 1.87. What is the ratio of the Gross enrolment ratio (%) of Pre-primary schools in Saudi Arabia to that in Seychelles?
Offer a terse response. 0.06. What is the ratio of the Gross enrolment ratio (%) of Primary schools in Saudi Arabia to that in Seychelles?
Ensure brevity in your answer.  0.65. What is the ratio of the Gross enrolment ratio (%) in Secondary schools in Saudi Arabia to that in Seychelles?
Offer a very short reply. 1.05. What is the ratio of the Gross enrolment ratio (%) in Tertiary schools in Saudi Arabia to that in Seychelles?
Offer a terse response. 13.79. What is the ratio of the Gross enrolment ratio (%) in Pre-primary schools in Saudi Arabia to that in Somalia?
Ensure brevity in your answer.  2.12. What is the ratio of the Gross enrolment ratio (%) in Primary schools in Saudi Arabia to that in Somalia?
Your answer should be compact. 0.58. What is the ratio of the Gross enrolment ratio (%) of Secondary schools in Saudi Arabia to that in Somalia?
Keep it short and to the point. 0.74. What is the ratio of the Gross enrolment ratio (%) in Tertiary schools in Saudi Arabia to that in Somalia?
Your response must be concise. 10.37. What is the ratio of the Gross enrolment ratio (%) in Pre-primary schools in Saudi Arabia to that in Spain?
Offer a terse response. 0.06. What is the ratio of the Gross enrolment ratio (%) in Primary schools in Saudi Arabia to that in Spain?
Offer a terse response. 1.06. What is the ratio of the Gross enrolment ratio (%) of Secondary schools in Saudi Arabia to that in Spain?
Your answer should be very brief. 1. What is the ratio of the Gross enrolment ratio (%) in Tertiary schools in Saudi Arabia to that in Spain?
Offer a terse response. 4.87. What is the ratio of the Gross enrolment ratio (%) of Pre-primary schools in Seychelles to that in Somalia?
Make the answer very short. 34.43. What is the ratio of the Gross enrolment ratio (%) in Primary schools in Seychelles to that in Somalia?
Give a very brief answer. 0.89. What is the ratio of the Gross enrolment ratio (%) in Secondary schools in Seychelles to that in Somalia?
Make the answer very short. 0.71. What is the ratio of the Gross enrolment ratio (%) of Tertiary schools in Seychelles to that in Somalia?
Offer a terse response. 0.75. What is the ratio of the Gross enrolment ratio (%) in Pre-primary schools in Seychelles to that in Spain?
Provide a succinct answer. 1.02. What is the ratio of the Gross enrolment ratio (%) of Primary schools in Seychelles to that in Spain?
Make the answer very short. 1.62. What is the ratio of the Gross enrolment ratio (%) of Secondary schools in Seychelles to that in Spain?
Provide a succinct answer. 0.95. What is the ratio of the Gross enrolment ratio (%) in Tertiary schools in Seychelles to that in Spain?
Make the answer very short. 0.35. What is the ratio of the Gross enrolment ratio (%) in Pre-primary schools in Somalia to that in Spain?
Your answer should be very brief. 0.03. What is the ratio of the Gross enrolment ratio (%) of Primary schools in Somalia to that in Spain?
Keep it short and to the point. 1.82. What is the ratio of the Gross enrolment ratio (%) in Secondary schools in Somalia to that in Spain?
Provide a succinct answer. 1.34. What is the ratio of the Gross enrolment ratio (%) in Tertiary schools in Somalia to that in Spain?
Offer a terse response. 0.47. What is the difference between the highest and the second highest Gross enrolment ratio (%) in Pre-primary schools?
Your response must be concise. 3.94. What is the difference between the highest and the second highest Gross enrolment ratio (%) of Primary schools?
Give a very brief answer. 26.19. What is the difference between the highest and the second highest Gross enrolment ratio (%) of Secondary schools?
Offer a very short reply. 0.38. What is the difference between the highest and the second highest Gross enrolment ratio (%) in Tertiary schools?
Make the answer very short. 4.01. What is the difference between the highest and the lowest Gross enrolment ratio (%) in Pre-primary schools?
Give a very brief answer. 59.96. What is the difference between the highest and the lowest Gross enrolment ratio (%) in Primary schools?
Offer a terse response. 113.71. What is the difference between the highest and the lowest Gross enrolment ratio (%) of Secondary schools?
Your answer should be very brief. 27.31. What is the difference between the highest and the lowest Gross enrolment ratio (%) of Tertiary schools?
Provide a succinct answer. 12.39. 